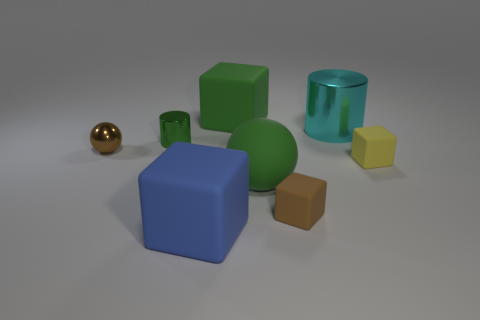Add 2 small blue metal cylinders. How many objects exist? 10 Subtract all cylinders. How many objects are left? 6 Add 7 cylinders. How many cylinders exist? 9 Subtract 0 gray cubes. How many objects are left? 8 Subtract all large green matte blocks. Subtract all big rubber things. How many objects are left? 4 Add 1 blue things. How many blue things are left? 2 